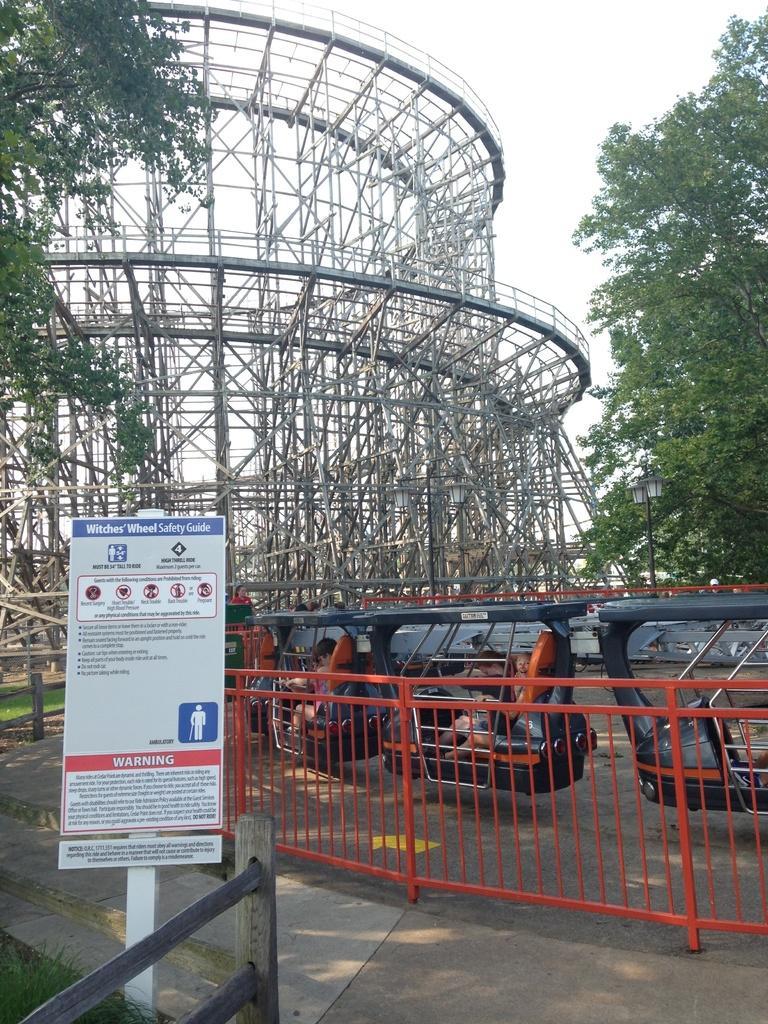Can you describe this image briefly? In this image there is a railing, behind the railing there is a park equipment, in which there are children's, behind that there is a huge metal structure. On the left and right side of the image there are trees and there is a board with some text. In front of that there is a wooden fence. In the background there is the sky. 